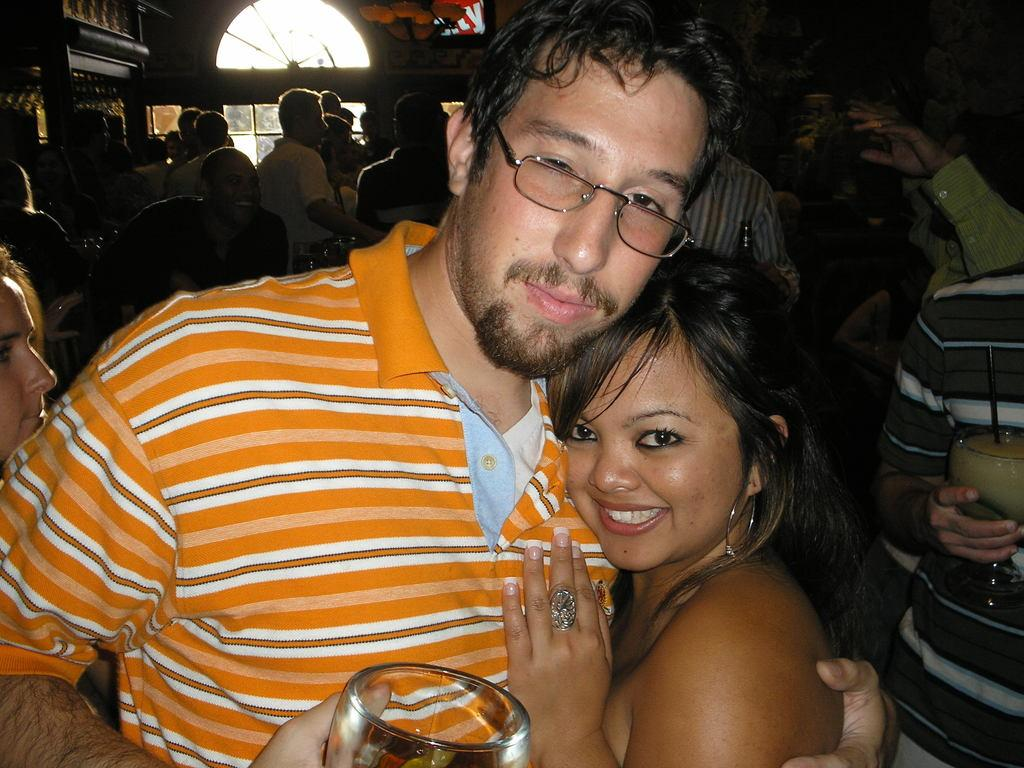What is the person in the image wearing? The person is wearing an orange t-shirt and glasses in the image. What is the person holding in their hand? The person is holding a glass in their hand. What is the person doing with the lady in the image? The person is holding a lady in the image. What can be seen in the background of the image? There are many people and a window in the background of the image. What type of expert advice can be heard from the person wearing the orange t-shirt in the image? There is no indication in the image that the person is providing expert advice or that any audio is present. 